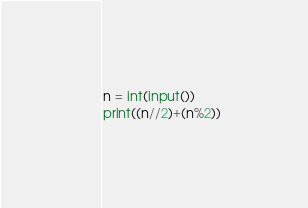Convert code to text. <code><loc_0><loc_0><loc_500><loc_500><_Python_>n = int(input())
print((n//2)+(n%2))</code> 